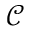<formula> <loc_0><loc_0><loc_500><loc_500>\mathcal { C }</formula> 